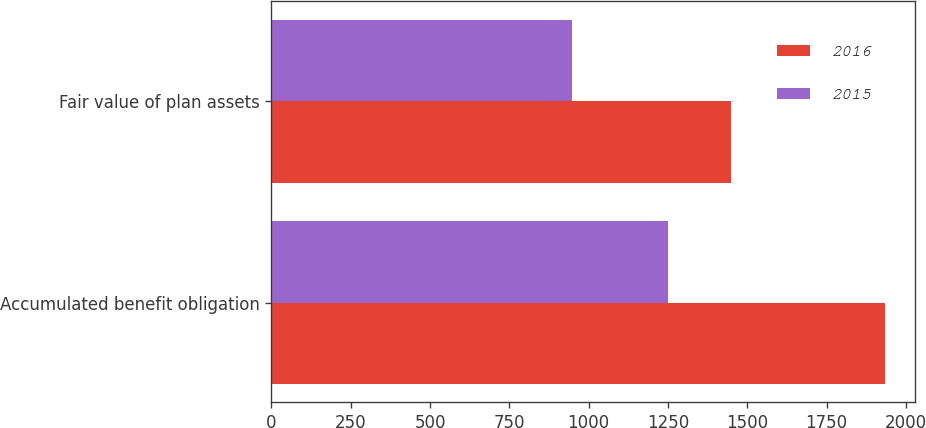Convert chart. <chart><loc_0><loc_0><loc_500><loc_500><stacked_bar_chart><ecel><fcel>Accumulated benefit obligation<fcel>Fair value of plan assets<nl><fcel>2016<fcel>1933.2<fcel>1449.5<nl><fcel>2015<fcel>1249.9<fcel>948.4<nl></chart> 